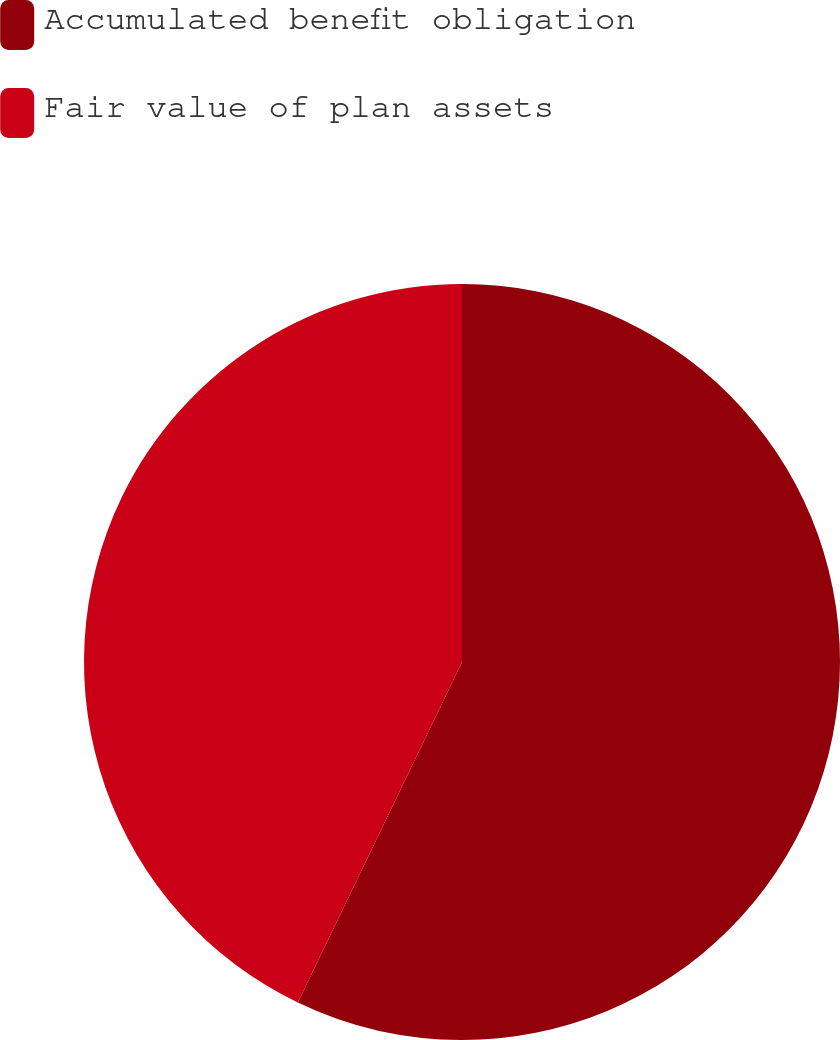Convert chart to OTSL. <chart><loc_0><loc_0><loc_500><loc_500><pie_chart><fcel>Accumulated benefit obligation<fcel>Fair value of plan assets<nl><fcel>57.15%<fcel>42.85%<nl></chart> 